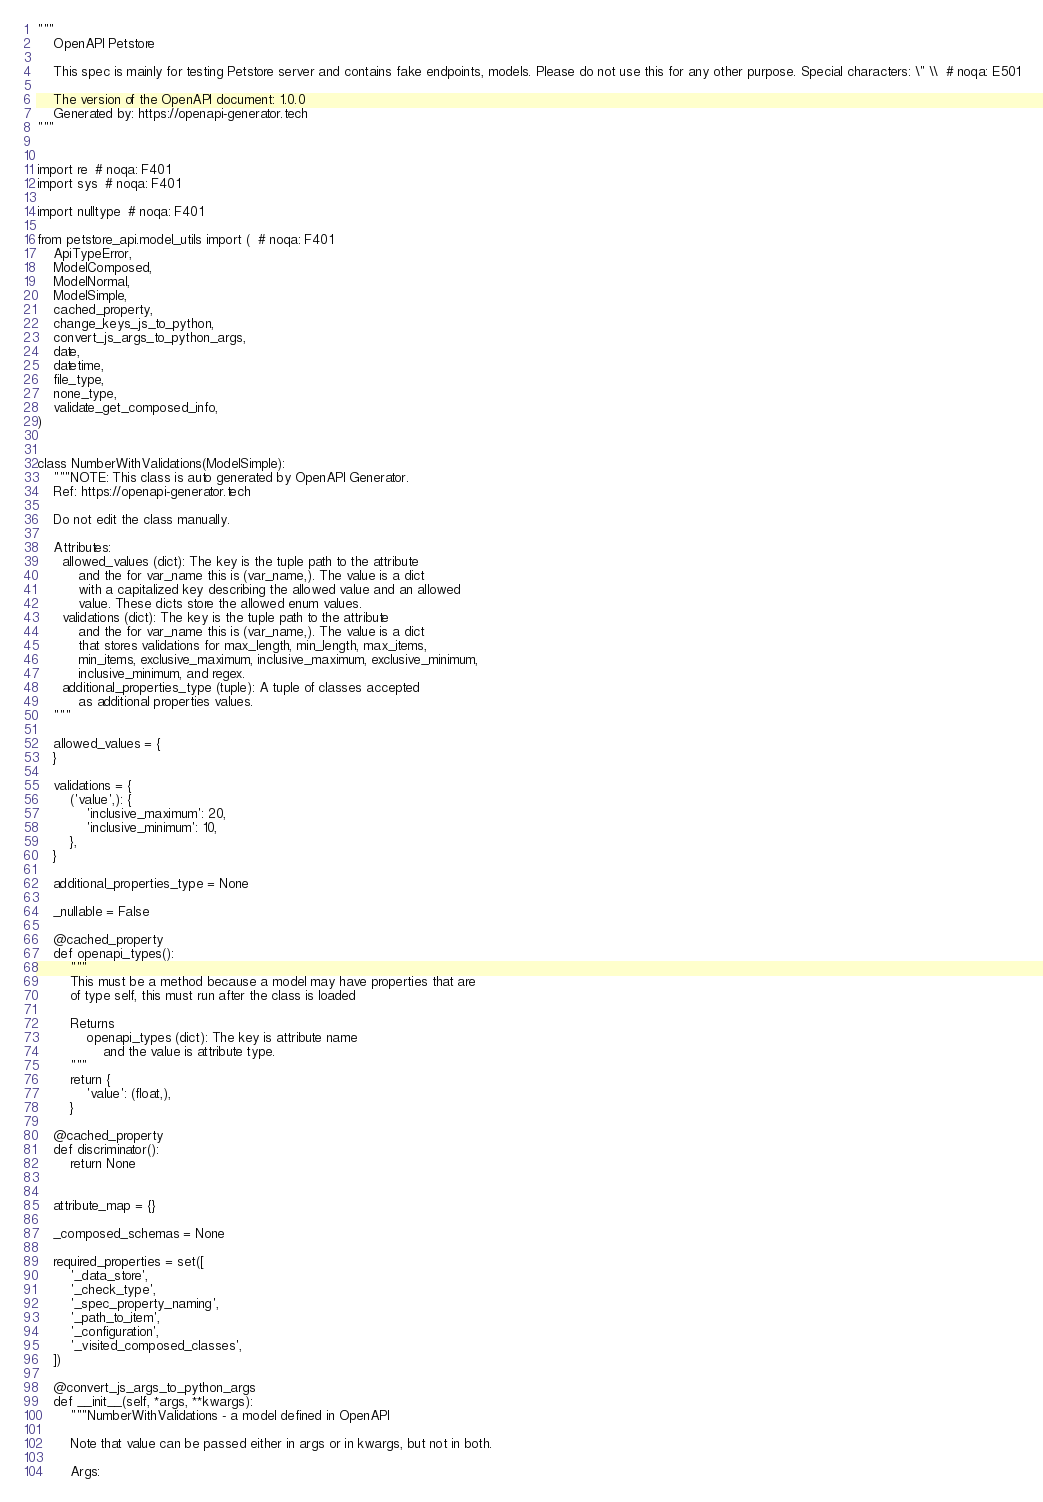<code> <loc_0><loc_0><loc_500><loc_500><_Python_>"""
    OpenAPI Petstore

    This spec is mainly for testing Petstore server and contains fake endpoints, models. Please do not use this for any other purpose. Special characters: \" \\  # noqa: E501

    The version of the OpenAPI document: 1.0.0
    Generated by: https://openapi-generator.tech
"""


import re  # noqa: F401
import sys  # noqa: F401

import nulltype  # noqa: F401

from petstore_api.model_utils import (  # noqa: F401
    ApiTypeError,
    ModelComposed,
    ModelNormal,
    ModelSimple,
    cached_property,
    change_keys_js_to_python,
    convert_js_args_to_python_args,
    date,
    datetime,
    file_type,
    none_type,
    validate_get_composed_info,
)


class NumberWithValidations(ModelSimple):
    """NOTE: This class is auto generated by OpenAPI Generator.
    Ref: https://openapi-generator.tech

    Do not edit the class manually.

    Attributes:
      allowed_values (dict): The key is the tuple path to the attribute
          and the for var_name this is (var_name,). The value is a dict
          with a capitalized key describing the allowed value and an allowed
          value. These dicts store the allowed enum values.
      validations (dict): The key is the tuple path to the attribute
          and the for var_name this is (var_name,). The value is a dict
          that stores validations for max_length, min_length, max_items,
          min_items, exclusive_maximum, inclusive_maximum, exclusive_minimum,
          inclusive_minimum, and regex.
      additional_properties_type (tuple): A tuple of classes accepted
          as additional properties values.
    """

    allowed_values = {
    }

    validations = {
        ('value',): {
            'inclusive_maximum': 20,
            'inclusive_minimum': 10,
        },
    }

    additional_properties_type = None

    _nullable = False

    @cached_property
    def openapi_types():
        """
        This must be a method because a model may have properties that are
        of type self, this must run after the class is loaded

        Returns
            openapi_types (dict): The key is attribute name
                and the value is attribute type.
        """
        return {
            'value': (float,),
        }

    @cached_property
    def discriminator():
        return None


    attribute_map = {}

    _composed_schemas = None

    required_properties = set([
        '_data_store',
        '_check_type',
        '_spec_property_naming',
        '_path_to_item',
        '_configuration',
        '_visited_composed_classes',
    ])

    @convert_js_args_to_python_args
    def __init__(self, *args, **kwargs):
        """NumberWithValidations - a model defined in OpenAPI

        Note that value can be passed either in args or in kwargs, but not in both.

        Args:</code> 